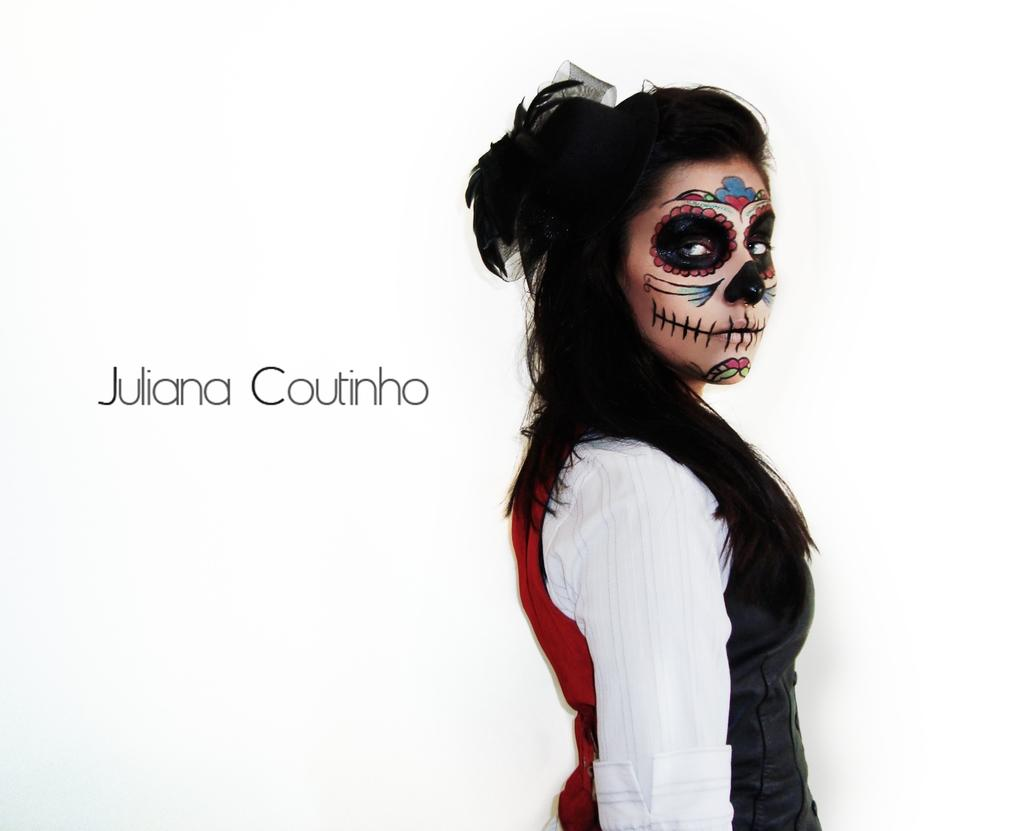Who is present in the image? There is a woman in the image. What color is the background of the image? The background of the image is white. What can be found on the white background? There is text written on the background. What type of birds are singing in the image? There are no birds or songs present in the image; it features a woman and text on a white background. 